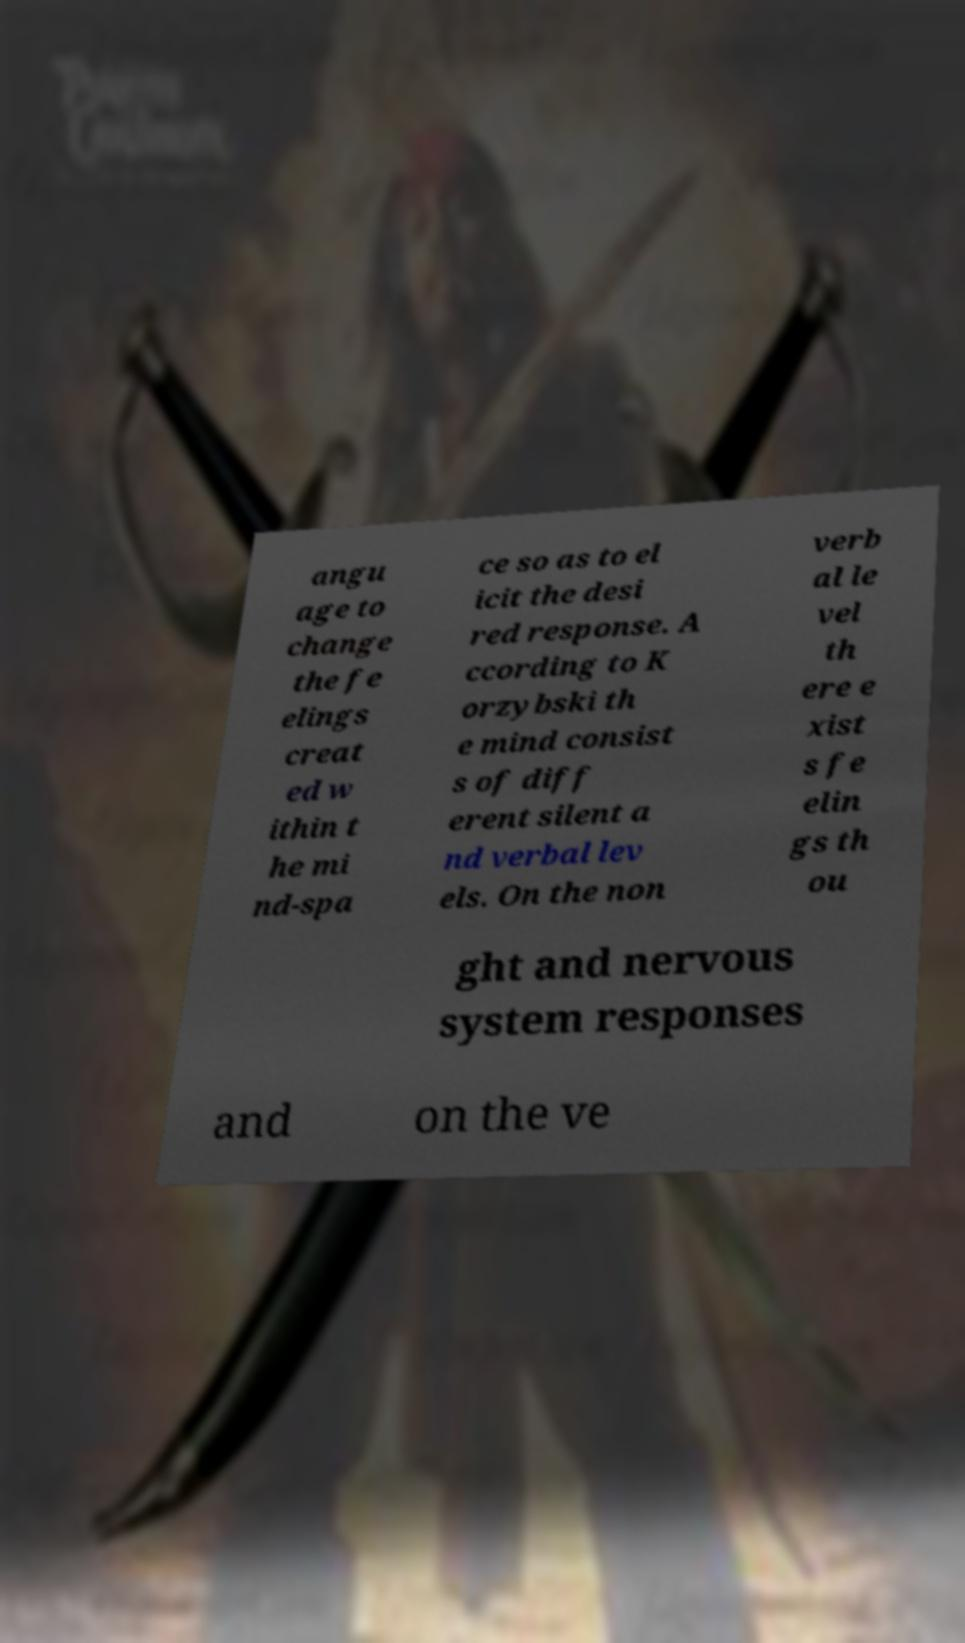What messages or text are displayed in this image? I need them in a readable, typed format. angu age to change the fe elings creat ed w ithin t he mi nd-spa ce so as to el icit the desi red response. A ccording to K orzybski th e mind consist s of diff erent silent a nd verbal lev els. On the non verb al le vel th ere e xist s fe elin gs th ou ght and nervous system responses and on the ve 